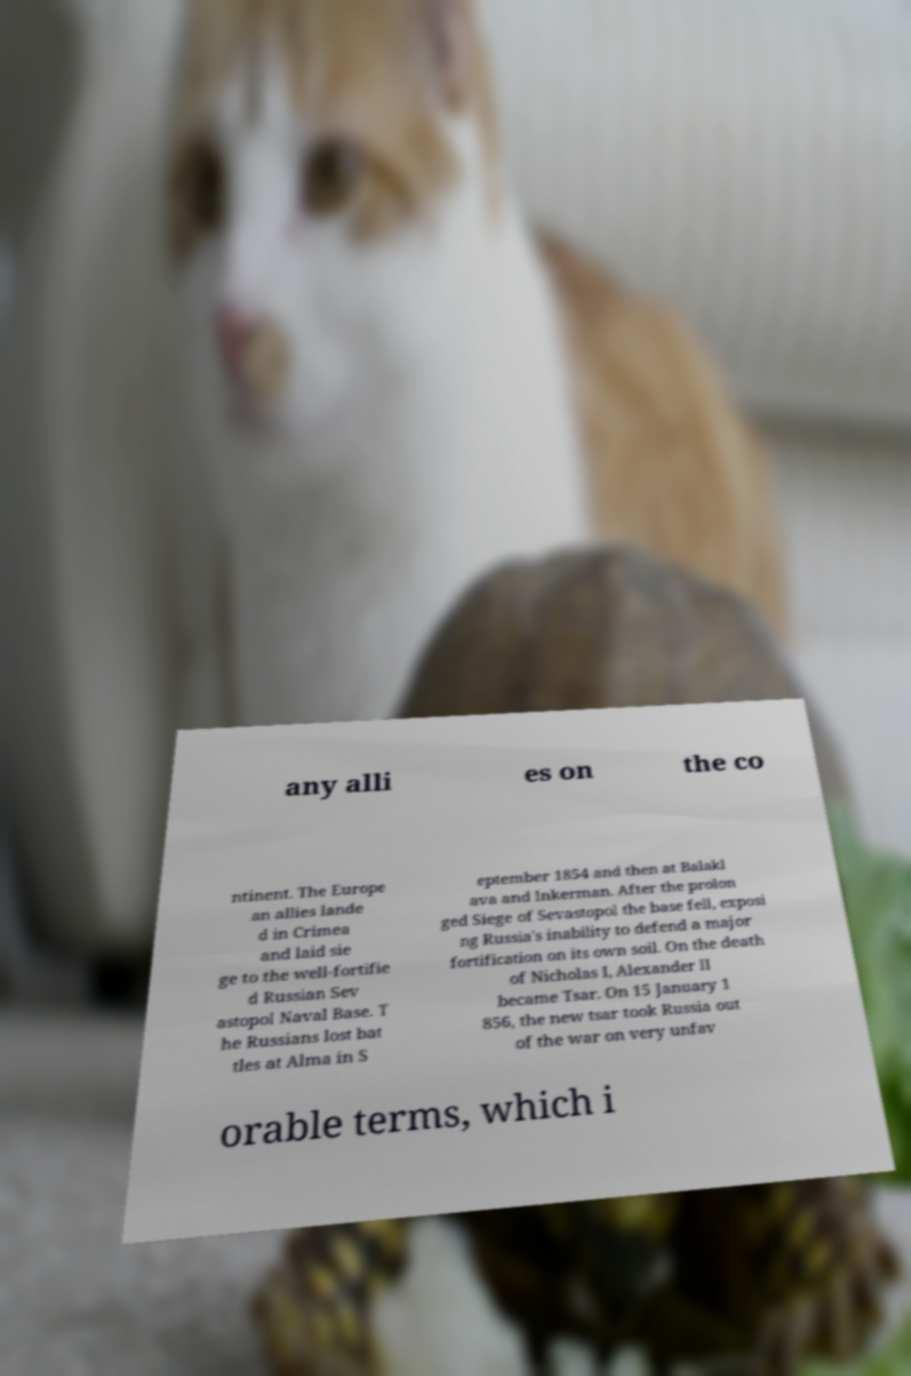What messages or text are displayed in this image? I need them in a readable, typed format. any alli es on the co ntinent. The Europe an allies lande d in Crimea and laid sie ge to the well-fortifie d Russian Sev astopol Naval Base. T he Russians lost bat tles at Alma in S eptember 1854 and then at Balakl ava and Inkerman. After the prolon ged Siege of Sevastopol the base fell, exposi ng Russia's inability to defend a major fortification on its own soil. On the death of Nicholas I, Alexander II became Tsar. On 15 January 1 856, the new tsar took Russia out of the war on very unfav orable terms, which i 